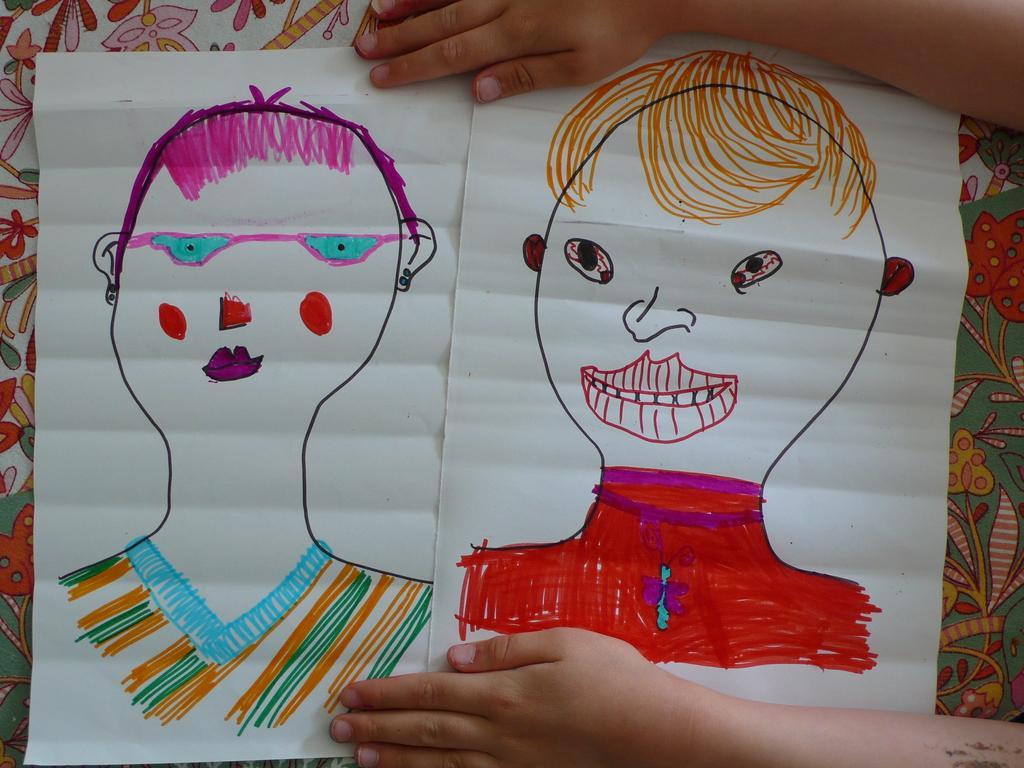Could you give a brief overview of what you see in this image? In this image we can see two sketches on the two different white color papers. We can see the human hand at the top and bottom of the image. We can see colorful sheet in the background. 